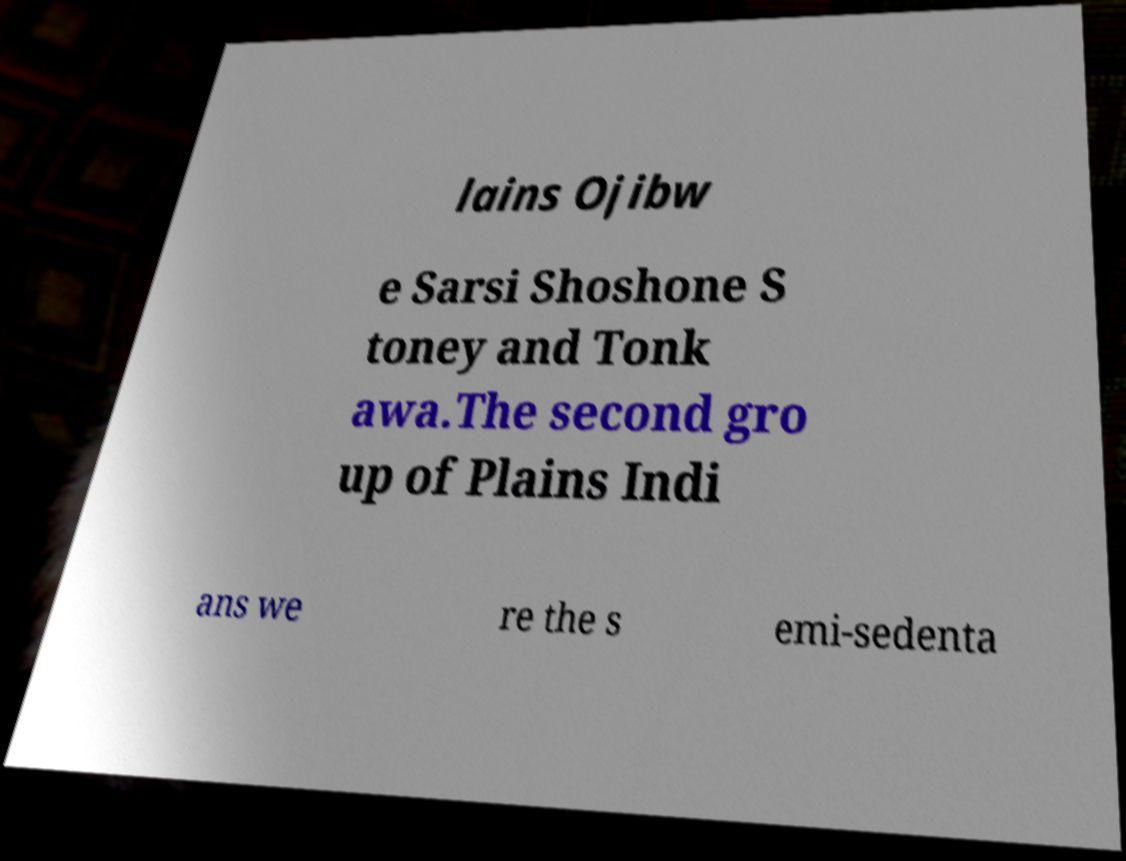What messages or text are displayed in this image? I need them in a readable, typed format. lains Ojibw e Sarsi Shoshone S toney and Tonk awa.The second gro up of Plains Indi ans we re the s emi-sedenta 